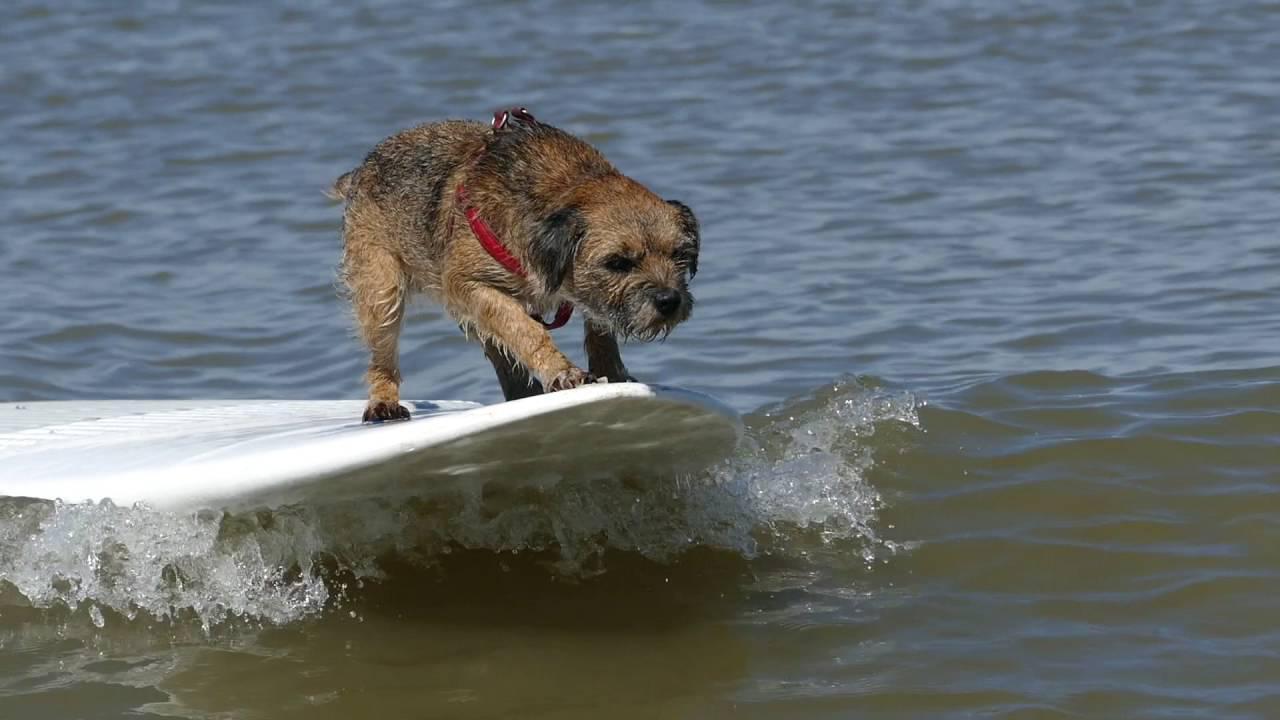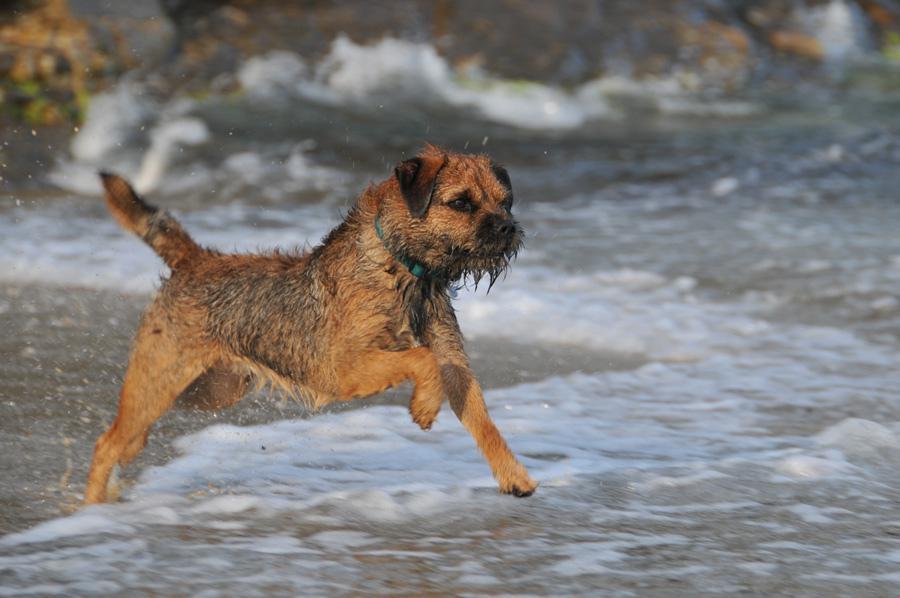The first image is the image on the left, the second image is the image on the right. Given the left and right images, does the statement "A forward-headed dog is staying afloat by means of some item that floats." hold true? Answer yes or no. Yes. The first image is the image on the left, the second image is the image on the right. Evaluate the accuracy of this statement regarding the images: "The dog in the image on the left is swimming in a pool.". Is it true? Answer yes or no. No. The first image is the image on the left, the second image is the image on the right. Evaluate the accuracy of this statement regarding the images: "In the image on the left, there isn't any body of water.". Is it true? Answer yes or no. No. 